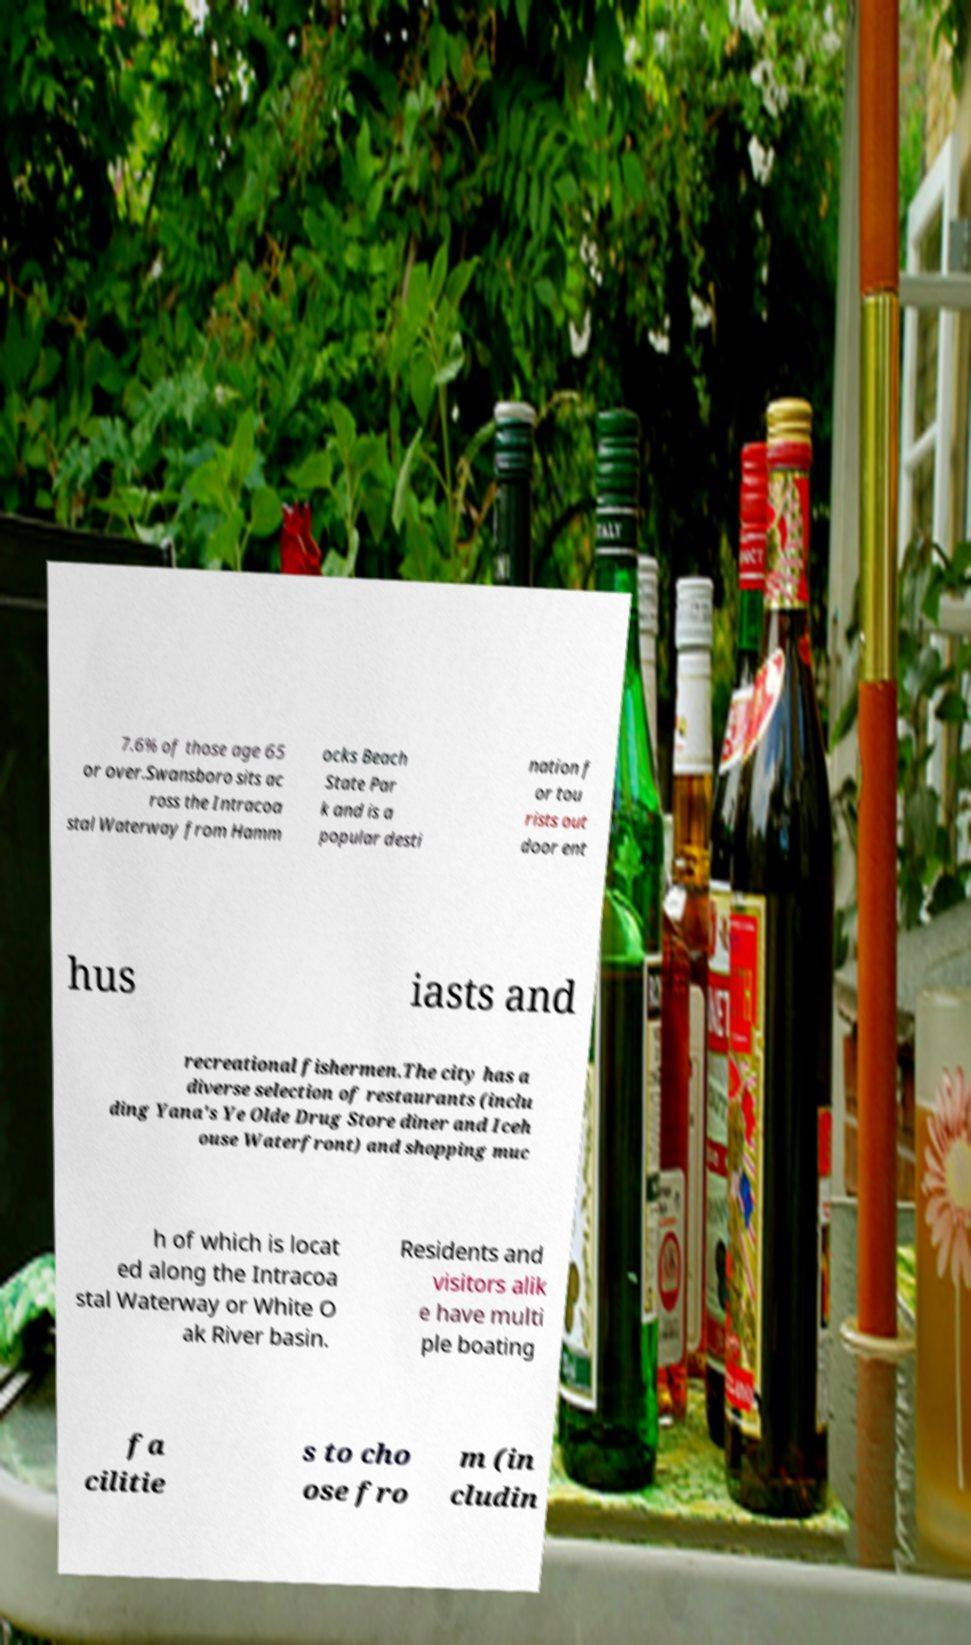What messages or text are displayed in this image? I need them in a readable, typed format. 7.6% of those age 65 or over.Swansboro sits ac ross the Intracoa stal Waterway from Hamm ocks Beach State Par k and is a popular desti nation f or tou rists out door ent hus iasts and recreational fishermen.The city has a diverse selection of restaurants (inclu ding Yana's Ye Olde Drug Store diner and Iceh ouse Waterfront) and shopping muc h of which is locat ed along the Intracoa stal Waterway or White O ak River basin. Residents and visitors alik e have multi ple boating fa cilitie s to cho ose fro m (in cludin 